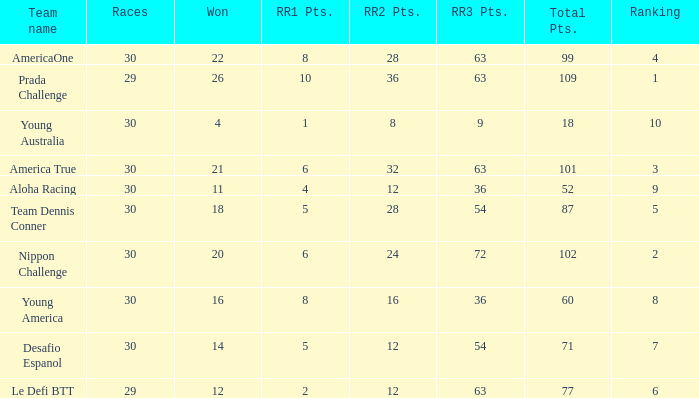Name the races for the prada challenge 29.0. 